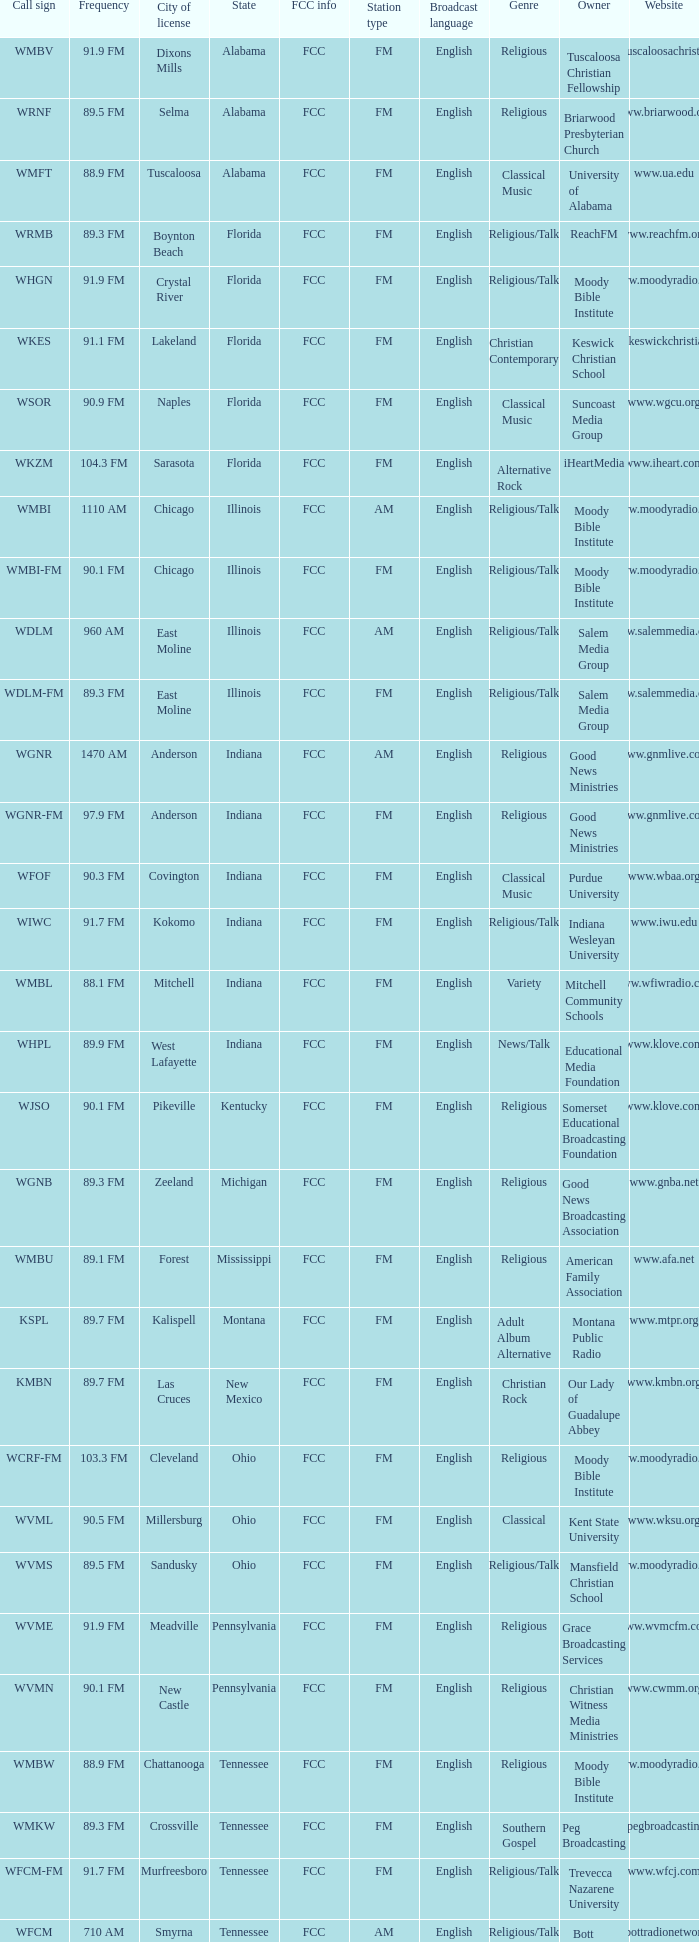What city is 103.3 FM licensed in? Cleveland. 